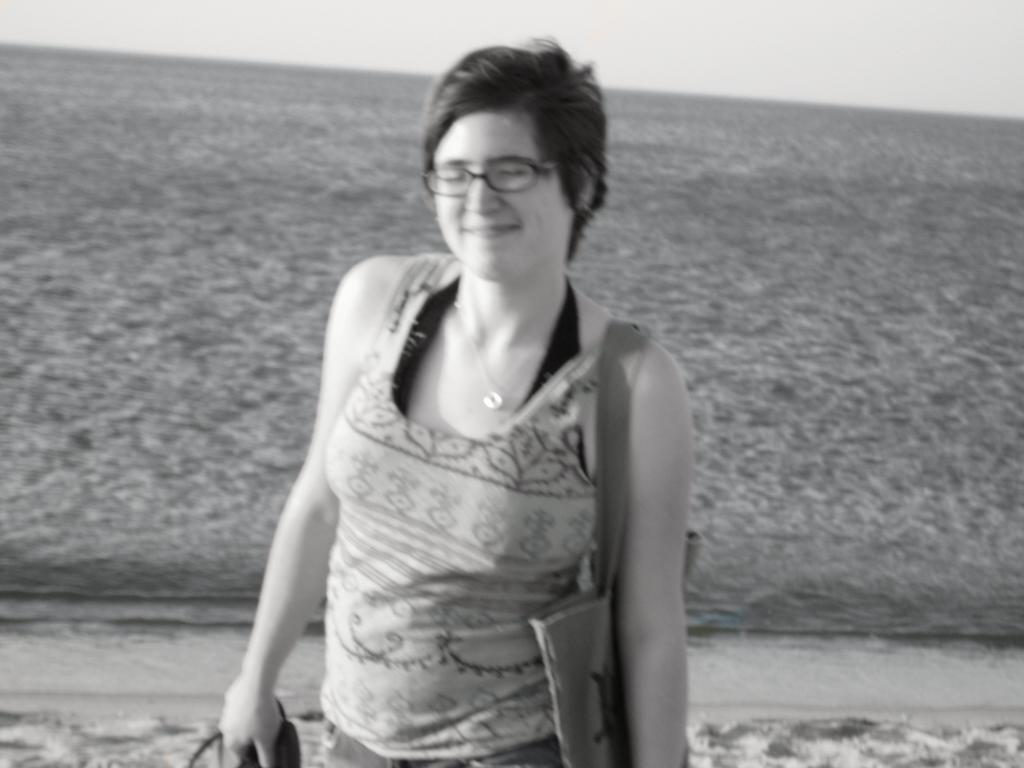What is the color scheme of the image? The image is black and white. Who is present in the image? There is a woman in the image. What is the woman wearing? The woman is wearing a T-shirt. Does the woman have any accessories? Yes, the woman has a bag and is wearing spectacles. What is the woman doing in the image? The woman has closed her eyes. What can be seen in the background of the image? The ground and the sky are visible in the background of the image. What type of corn can be seen growing in the image? There is no corn present in the image; it is a black and white image of a woman with her eyes closed. 